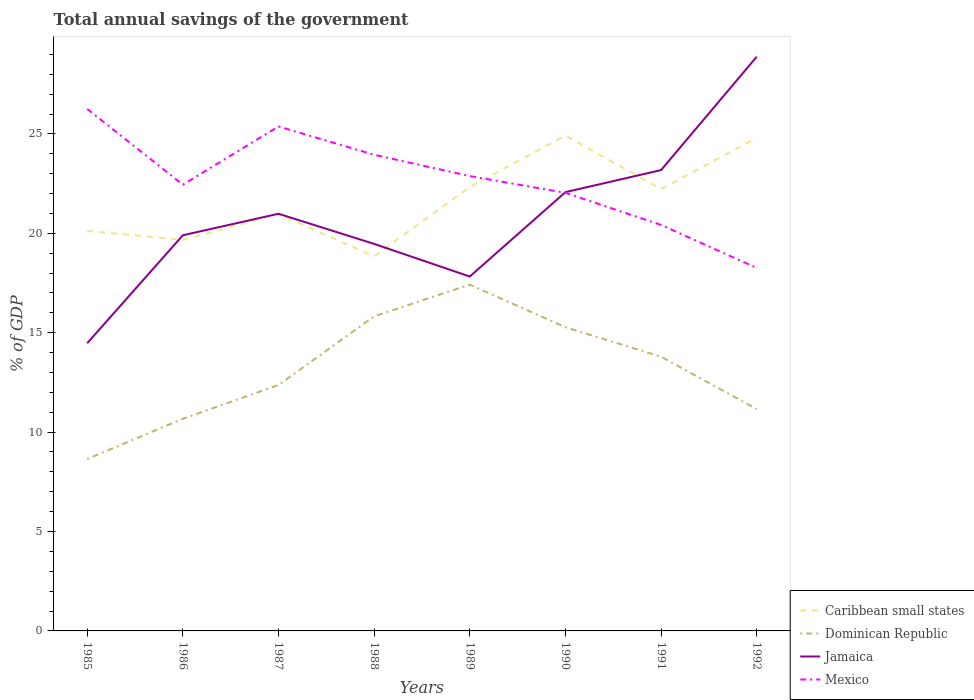Does the line corresponding to Jamaica intersect with the line corresponding to Caribbean small states?
Ensure brevity in your answer.  Yes. Across all years, what is the maximum total annual savings of the government in Dominican Republic?
Provide a succinct answer. 8.65. In which year was the total annual savings of the government in Caribbean small states maximum?
Make the answer very short. 1988. What is the total total annual savings of the government in Mexico in the graph?
Offer a terse response. 0.41. What is the difference between the highest and the second highest total annual savings of the government in Caribbean small states?
Keep it short and to the point. 6.07. Is the total annual savings of the government in Jamaica strictly greater than the total annual savings of the government in Mexico over the years?
Your response must be concise. No. What is the difference between two consecutive major ticks on the Y-axis?
Keep it short and to the point. 5. Are the values on the major ticks of Y-axis written in scientific E-notation?
Your answer should be very brief. No. How are the legend labels stacked?
Your answer should be very brief. Vertical. What is the title of the graph?
Offer a very short reply. Total annual savings of the government. What is the label or title of the Y-axis?
Provide a succinct answer. % of GDP. What is the % of GDP of Caribbean small states in 1985?
Provide a succinct answer. 20.12. What is the % of GDP in Dominican Republic in 1985?
Offer a very short reply. 8.65. What is the % of GDP in Jamaica in 1985?
Ensure brevity in your answer.  14.47. What is the % of GDP of Mexico in 1985?
Ensure brevity in your answer.  26.26. What is the % of GDP of Caribbean small states in 1986?
Keep it short and to the point. 19.67. What is the % of GDP of Dominican Republic in 1986?
Offer a terse response. 10.67. What is the % of GDP of Jamaica in 1986?
Your answer should be compact. 19.9. What is the % of GDP of Mexico in 1986?
Your answer should be very brief. 22.44. What is the % of GDP of Caribbean small states in 1987?
Offer a terse response. 20.96. What is the % of GDP in Dominican Republic in 1987?
Give a very brief answer. 12.37. What is the % of GDP of Jamaica in 1987?
Your answer should be very brief. 20.98. What is the % of GDP of Mexico in 1987?
Offer a very short reply. 25.37. What is the % of GDP of Caribbean small states in 1988?
Your answer should be very brief. 18.84. What is the % of GDP in Dominican Republic in 1988?
Keep it short and to the point. 15.82. What is the % of GDP of Jamaica in 1988?
Provide a short and direct response. 19.47. What is the % of GDP in Mexico in 1988?
Your answer should be compact. 23.95. What is the % of GDP of Caribbean small states in 1989?
Ensure brevity in your answer.  22.33. What is the % of GDP of Dominican Republic in 1989?
Your answer should be compact. 17.42. What is the % of GDP of Jamaica in 1989?
Ensure brevity in your answer.  17.83. What is the % of GDP in Mexico in 1989?
Offer a very short reply. 22.88. What is the % of GDP in Caribbean small states in 1990?
Your answer should be compact. 24.92. What is the % of GDP in Dominican Republic in 1990?
Give a very brief answer. 15.28. What is the % of GDP of Jamaica in 1990?
Your response must be concise. 22.07. What is the % of GDP of Mexico in 1990?
Offer a terse response. 22.04. What is the % of GDP in Caribbean small states in 1991?
Ensure brevity in your answer.  22.22. What is the % of GDP in Dominican Republic in 1991?
Your answer should be compact. 13.79. What is the % of GDP of Jamaica in 1991?
Offer a terse response. 23.18. What is the % of GDP of Mexico in 1991?
Offer a very short reply. 20.42. What is the % of GDP in Caribbean small states in 1992?
Offer a very short reply. 24.8. What is the % of GDP of Dominican Republic in 1992?
Make the answer very short. 11.16. What is the % of GDP of Jamaica in 1992?
Your response must be concise. 28.88. What is the % of GDP of Mexico in 1992?
Offer a very short reply. 18.26. Across all years, what is the maximum % of GDP in Caribbean small states?
Provide a succinct answer. 24.92. Across all years, what is the maximum % of GDP of Dominican Republic?
Offer a very short reply. 17.42. Across all years, what is the maximum % of GDP of Jamaica?
Give a very brief answer. 28.88. Across all years, what is the maximum % of GDP of Mexico?
Keep it short and to the point. 26.26. Across all years, what is the minimum % of GDP in Caribbean small states?
Provide a succinct answer. 18.84. Across all years, what is the minimum % of GDP in Dominican Republic?
Provide a short and direct response. 8.65. Across all years, what is the minimum % of GDP of Jamaica?
Offer a very short reply. 14.47. Across all years, what is the minimum % of GDP in Mexico?
Your answer should be very brief. 18.26. What is the total % of GDP of Caribbean small states in the graph?
Give a very brief answer. 173.86. What is the total % of GDP of Dominican Republic in the graph?
Give a very brief answer. 105.15. What is the total % of GDP of Jamaica in the graph?
Offer a very short reply. 166.78. What is the total % of GDP of Mexico in the graph?
Your response must be concise. 181.62. What is the difference between the % of GDP in Caribbean small states in 1985 and that in 1986?
Your answer should be compact. 0.45. What is the difference between the % of GDP in Dominican Republic in 1985 and that in 1986?
Your answer should be very brief. -2.02. What is the difference between the % of GDP of Jamaica in 1985 and that in 1986?
Your answer should be very brief. -5.43. What is the difference between the % of GDP of Mexico in 1985 and that in 1986?
Your response must be concise. 3.81. What is the difference between the % of GDP of Caribbean small states in 1985 and that in 1987?
Your answer should be compact. -0.84. What is the difference between the % of GDP in Dominican Republic in 1985 and that in 1987?
Offer a terse response. -3.72. What is the difference between the % of GDP of Jamaica in 1985 and that in 1987?
Make the answer very short. -6.51. What is the difference between the % of GDP in Mexico in 1985 and that in 1987?
Give a very brief answer. 0.88. What is the difference between the % of GDP in Caribbean small states in 1985 and that in 1988?
Offer a terse response. 1.28. What is the difference between the % of GDP in Dominican Republic in 1985 and that in 1988?
Your response must be concise. -7.18. What is the difference between the % of GDP in Jamaica in 1985 and that in 1988?
Give a very brief answer. -5. What is the difference between the % of GDP in Mexico in 1985 and that in 1988?
Keep it short and to the point. 2.31. What is the difference between the % of GDP in Caribbean small states in 1985 and that in 1989?
Ensure brevity in your answer.  -2.21. What is the difference between the % of GDP in Dominican Republic in 1985 and that in 1989?
Your response must be concise. -8.77. What is the difference between the % of GDP of Jamaica in 1985 and that in 1989?
Your response must be concise. -3.35. What is the difference between the % of GDP in Mexico in 1985 and that in 1989?
Your response must be concise. 3.38. What is the difference between the % of GDP in Caribbean small states in 1985 and that in 1990?
Make the answer very short. -4.8. What is the difference between the % of GDP in Dominican Republic in 1985 and that in 1990?
Provide a succinct answer. -6.63. What is the difference between the % of GDP in Jamaica in 1985 and that in 1990?
Provide a short and direct response. -7.6. What is the difference between the % of GDP in Mexico in 1985 and that in 1990?
Make the answer very short. 4.22. What is the difference between the % of GDP of Caribbean small states in 1985 and that in 1991?
Make the answer very short. -2.1. What is the difference between the % of GDP of Dominican Republic in 1985 and that in 1991?
Provide a succinct answer. -5.14. What is the difference between the % of GDP in Jamaica in 1985 and that in 1991?
Ensure brevity in your answer.  -8.71. What is the difference between the % of GDP of Mexico in 1985 and that in 1991?
Ensure brevity in your answer.  5.84. What is the difference between the % of GDP in Caribbean small states in 1985 and that in 1992?
Give a very brief answer. -4.68. What is the difference between the % of GDP in Dominican Republic in 1985 and that in 1992?
Offer a very short reply. -2.51. What is the difference between the % of GDP in Jamaica in 1985 and that in 1992?
Your response must be concise. -14.41. What is the difference between the % of GDP in Mexico in 1985 and that in 1992?
Your response must be concise. 8. What is the difference between the % of GDP in Caribbean small states in 1986 and that in 1987?
Provide a succinct answer. -1.29. What is the difference between the % of GDP of Dominican Republic in 1986 and that in 1987?
Offer a terse response. -1.7. What is the difference between the % of GDP in Jamaica in 1986 and that in 1987?
Ensure brevity in your answer.  -1.08. What is the difference between the % of GDP of Mexico in 1986 and that in 1987?
Offer a very short reply. -2.93. What is the difference between the % of GDP of Caribbean small states in 1986 and that in 1988?
Offer a very short reply. 0.83. What is the difference between the % of GDP in Dominican Republic in 1986 and that in 1988?
Keep it short and to the point. -5.15. What is the difference between the % of GDP in Jamaica in 1986 and that in 1988?
Give a very brief answer. 0.43. What is the difference between the % of GDP of Mexico in 1986 and that in 1988?
Give a very brief answer. -1.51. What is the difference between the % of GDP of Caribbean small states in 1986 and that in 1989?
Offer a terse response. -2.66. What is the difference between the % of GDP of Dominican Republic in 1986 and that in 1989?
Ensure brevity in your answer.  -6.75. What is the difference between the % of GDP of Jamaica in 1986 and that in 1989?
Offer a terse response. 2.08. What is the difference between the % of GDP of Mexico in 1986 and that in 1989?
Keep it short and to the point. -0.43. What is the difference between the % of GDP in Caribbean small states in 1986 and that in 1990?
Give a very brief answer. -5.25. What is the difference between the % of GDP of Dominican Republic in 1986 and that in 1990?
Offer a terse response. -4.6. What is the difference between the % of GDP of Jamaica in 1986 and that in 1990?
Offer a very short reply. -2.17. What is the difference between the % of GDP in Mexico in 1986 and that in 1990?
Offer a terse response. 0.41. What is the difference between the % of GDP of Caribbean small states in 1986 and that in 1991?
Provide a succinct answer. -2.55. What is the difference between the % of GDP of Dominican Republic in 1986 and that in 1991?
Your answer should be very brief. -3.12. What is the difference between the % of GDP in Jamaica in 1986 and that in 1991?
Ensure brevity in your answer.  -3.28. What is the difference between the % of GDP in Mexico in 1986 and that in 1991?
Your response must be concise. 2.02. What is the difference between the % of GDP in Caribbean small states in 1986 and that in 1992?
Your answer should be compact. -5.13. What is the difference between the % of GDP in Dominican Republic in 1986 and that in 1992?
Your answer should be very brief. -0.49. What is the difference between the % of GDP in Jamaica in 1986 and that in 1992?
Offer a very short reply. -8.98. What is the difference between the % of GDP of Mexico in 1986 and that in 1992?
Make the answer very short. 4.19. What is the difference between the % of GDP of Caribbean small states in 1987 and that in 1988?
Keep it short and to the point. 2.12. What is the difference between the % of GDP of Dominican Republic in 1987 and that in 1988?
Provide a short and direct response. -3.46. What is the difference between the % of GDP in Jamaica in 1987 and that in 1988?
Give a very brief answer. 1.52. What is the difference between the % of GDP in Mexico in 1987 and that in 1988?
Your answer should be very brief. 1.42. What is the difference between the % of GDP in Caribbean small states in 1987 and that in 1989?
Offer a very short reply. -1.37. What is the difference between the % of GDP of Dominican Republic in 1987 and that in 1989?
Offer a very short reply. -5.05. What is the difference between the % of GDP of Jamaica in 1987 and that in 1989?
Make the answer very short. 3.16. What is the difference between the % of GDP of Mexico in 1987 and that in 1989?
Keep it short and to the point. 2.49. What is the difference between the % of GDP of Caribbean small states in 1987 and that in 1990?
Provide a succinct answer. -3.96. What is the difference between the % of GDP in Dominican Republic in 1987 and that in 1990?
Provide a short and direct response. -2.91. What is the difference between the % of GDP in Jamaica in 1987 and that in 1990?
Your answer should be compact. -1.09. What is the difference between the % of GDP in Mexico in 1987 and that in 1990?
Keep it short and to the point. 3.34. What is the difference between the % of GDP in Caribbean small states in 1987 and that in 1991?
Provide a succinct answer. -1.26. What is the difference between the % of GDP in Dominican Republic in 1987 and that in 1991?
Ensure brevity in your answer.  -1.42. What is the difference between the % of GDP in Jamaica in 1987 and that in 1991?
Your answer should be very brief. -2.2. What is the difference between the % of GDP of Mexico in 1987 and that in 1991?
Ensure brevity in your answer.  4.95. What is the difference between the % of GDP in Caribbean small states in 1987 and that in 1992?
Offer a terse response. -3.84. What is the difference between the % of GDP in Dominican Republic in 1987 and that in 1992?
Offer a terse response. 1.21. What is the difference between the % of GDP in Jamaica in 1987 and that in 1992?
Offer a very short reply. -7.9. What is the difference between the % of GDP of Mexico in 1987 and that in 1992?
Your answer should be very brief. 7.12. What is the difference between the % of GDP in Caribbean small states in 1988 and that in 1989?
Your answer should be compact. -3.49. What is the difference between the % of GDP of Dominican Republic in 1988 and that in 1989?
Provide a short and direct response. -1.59. What is the difference between the % of GDP of Jamaica in 1988 and that in 1989?
Your response must be concise. 1.64. What is the difference between the % of GDP in Mexico in 1988 and that in 1989?
Ensure brevity in your answer.  1.07. What is the difference between the % of GDP of Caribbean small states in 1988 and that in 1990?
Your answer should be compact. -6.07. What is the difference between the % of GDP in Dominican Republic in 1988 and that in 1990?
Give a very brief answer. 0.55. What is the difference between the % of GDP in Jamaica in 1988 and that in 1990?
Your response must be concise. -2.6. What is the difference between the % of GDP in Mexico in 1988 and that in 1990?
Your response must be concise. 1.91. What is the difference between the % of GDP in Caribbean small states in 1988 and that in 1991?
Your answer should be very brief. -3.38. What is the difference between the % of GDP of Dominican Republic in 1988 and that in 1991?
Your response must be concise. 2.03. What is the difference between the % of GDP of Jamaica in 1988 and that in 1991?
Ensure brevity in your answer.  -3.71. What is the difference between the % of GDP of Mexico in 1988 and that in 1991?
Your answer should be compact. 3.53. What is the difference between the % of GDP in Caribbean small states in 1988 and that in 1992?
Your response must be concise. -5.96. What is the difference between the % of GDP in Dominican Republic in 1988 and that in 1992?
Provide a short and direct response. 4.67. What is the difference between the % of GDP in Jamaica in 1988 and that in 1992?
Your answer should be very brief. -9.42. What is the difference between the % of GDP in Mexico in 1988 and that in 1992?
Provide a short and direct response. 5.69. What is the difference between the % of GDP in Caribbean small states in 1989 and that in 1990?
Your answer should be very brief. -2.59. What is the difference between the % of GDP of Dominican Republic in 1989 and that in 1990?
Your answer should be very brief. 2.14. What is the difference between the % of GDP of Jamaica in 1989 and that in 1990?
Give a very brief answer. -4.25. What is the difference between the % of GDP of Mexico in 1989 and that in 1990?
Offer a terse response. 0.84. What is the difference between the % of GDP of Caribbean small states in 1989 and that in 1991?
Ensure brevity in your answer.  0.11. What is the difference between the % of GDP of Dominican Republic in 1989 and that in 1991?
Your answer should be compact. 3.63. What is the difference between the % of GDP in Jamaica in 1989 and that in 1991?
Offer a terse response. -5.35. What is the difference between the % of GDP of Mexico in 1989 and that in 1991?
Offer a very short reply. 2.46. What is the difference between the % of GDP of Caribbean small states in 1989 and that in 1992?
Offer a very short reply. -2.47. What is the difference between the % of GDP of Dominican Republic in 1989 and that in 1992?
Provide a succinct answer. 6.26. What is the difference between the % of GDP of Jamaica in 1989 and that in 1992?
Provide a succinct answer. -11.06. What is the difference between the % of GDP of Mexico in 1989 and that in 1992?
Provide a short and direct response. 4.62. What is the difference between the % of GDP of Caribbean small states in 1990 and that in 1991?
Offer a terse response. 2.7. What is the difference between the % of GDP in Dominican Republic in 1990 and that in 1991?
Ensure brevity in your answer.  1.49. What is the difference between the % of GDP of Jamaica in 1990 and that in 1991?
Provide a short and direct response. -1.11. What is the difference between the % of GDP of Mexico in 1990 and that in 1991?
Provide a short and direct response. 1.62. What is the difference between the % of GDP in Caribbean small states in 1990 and that in 1992?
Give a very brief answer. 0.11. What is the difference between the % of GDP in Dominican Republic in 1990 and that in 1992?
Offer a terse response. 4.12. What is the difference between the % of GDP in Jamaica in 1990 and that in 1992?
Provide a succinct answer. -6.81. What is the difference between the % of GDP in Mexico in 1990 and that in 1992?
Your answer should be compact. 3.78. What is the difference between the % of GDP in Caribbean small states in 1991 and that in 1992?
Offer a very short reply. -2.58. What is the difference between the % of GDP of Dominican Republic in 1991 and that in 1992?
Your response must be concise. 2.63. What is the difference between the % of GDP of Jamaica in 1991 and that in 1992?
Your response must be concise. -5.7. What is the difference between the % of GDP in Mexico in 1991 and that in 1992?
Your answer should be very brief. 2.16. What is the difference between the % of GDP in Caribbean small states in 1985 and the % of GDP in Dominican Republic in 1986?
Provide a succinct answer. 9.45. What is the difference between the % of GDP in Caribbean small states in 1985 and the % of GDP in Jamaica in 1986?
Your response must be concise. 0.22. What is the difference between the % of GDP of Caribbean small states in 1985 and the % of GDP of Mexico in 1986?
Make the answer very short. -2.32. What is the difference between the % of GDP of Dominican Republic in 1985 and the % of GDP of Jamaica in 1986?
Provide a short and direct response. -11.25. What is the difference between the % of GDP of Dominican Republic in 1985 and the % of GDP of Mexico in 1986?
Your answer should be compact. -13.8. What is the difference between the % of GDP in Jamaica in 1985 and the % of GDP in Mexico in 1986?
Your answer should be compact. -7.97. What is the difference between the % of GDP in Caribbean small states in 1985 and the % of GDP in Dominican Republic in 1987?
Offer a terse response. 7.75. What is the difference between the % of GDP of Caribbean small states in 1985 and the % of GDP of Jamaica in 1987?
Your answer should be compact. -0.86. What is the difference between the % of GDP of Caribbean small states in 1985 and the % of GDP of Mexico in 1987?
Your response must be concise. -5.25. What is the difference between the % of GDP in Dominican Republic in 1985 and the % of GDP in Jamaica in 1987?
Keep it short and to the point. -12.34. What is the difference between the % of GDP of Dominican Republic in 1985 and the % of GDP of Mexico in 1987?
Your answer should be very brief. -16.73. What is the difference between the % of GDP in Jamaica in 1985 and the % of GDP in Mexico in 1987?
Offer a terse response. -10.9. What is the difference between the % of GDP of Caribbean small states in 1985 and the % of GDP of Dominican Republic in 1988?
Your answer should be very brief. 4.3. What is the difference between the % of GDP in Caribbean small states in 1985 and the % of GDP in Jamaica in 1988?
Your answer should be compact. 0.65. What is the difference between the % of GDP in Caribbean small states in 1985 and the % of GDP in Mexico in 1988?
Your answer should be compact. -3.83. What is the difference between the % of GDP in Dominican Republic in 1985 and the % of GDP in Jamaica in 1988?
Your answer should be very brief. -10.82. What is the difference between the % of GDP in Dominican Republic in 1985 and the % of GDP in Mexico in 1988?
Provide a succinct answer. -15.3. What is the difference between the % of GDP of Jamaica in 1985 and the % of GDP of Mexico in 1988?
Your answer should be compact. -9.48. What is the difference between the % of GDP of Caribbean small states in 1985 and the % of GDP of Dominican Republic in 1989?
Your response must be concise. 2.7. What is the difference between the % of GDP of Caribbean small states in 1985 and the % of GDP of Jamaica in 1989?
Offer a terse response. 2.29. What is the difference between the % of GDP in Caribbean small states in 1985 and the % of GDP in Mexico in 1989?
Give a very brief answer. -2.76. What is the difference between the % of GDP in Dominican Republic in 1985 and the % of GDP in Jamaica in 1989?
Offer a terse response. -9.18. What is the difference between the % of GDP of Dominican Republic in 1985 and the % of GDP of Mexico in 1989?
Make the answer very short. -14.23. What is the difference between the % of GDP of Jamaica in 1985 and the % of GDP of Mexico in 1989?
Your answer should be compact. -8.41. What is the difference between the % of GDP in Caribbean small states in 1985 and the % of GDP in Dominican Republic in 1990?
Provide a succinct answer. 4.84. What is the difference between the % of GDP of Caribbean small states in 1985 and the % of GDP of Jamaica in 1990?
Provide a succinct answer. -1.95. What is the difference between the % of GDP in Caribbean small states in 1985 and the % of GDP in Mexico in 1990?
Offer a terse response. -1.92. What is the difference between the % of GDP of Dominican Republic in 1985 and the % of GDP of Jamaica in 1990?
Your answer should be compact. -13.42. What is the difference between the % of GDP in Dominican Republic in 1985 and the % of GDP in Mexico in 1990?
Your answer should be very brief. -13.39. What is the difference between the % of GDP of Jamaica in 1985 and the % of GDP of Mexico in 1990?
Offer a very short reply. -7.57. What is the difference between the % of GDP in Caribbean small states in 1985 and the % of GDP in Dominican Republic in 1991?
Ensure brevity in your answer.  6.33. What is the difference between the % of GDP of Caribbean small states in 1985 and the % of GDP of Jamaica in 1991?
Offer a very short reply. -3.06. What is the difference between the % of GDP of Caribbean small states in 1985 and the % of GDP of Mexico in 1991?
Your answer should be compact. -0.3. What is the difference between the % of GDP of Dominican Republic in 1985 and the % of GDP of Jamaica in 1991?
Your answer should be compact. -14.53. What is the difference between the % of GDP in Dominican Republic in 1985 and the % of GDP in Mexico in 1991?
Your answer should be compact. -11.78. What is the difference between the % of GDP of Jamaica in 1985 and the % of GDP of Mexico in 1991?
Provide a short and direct response. -5.95. What is the difference between the % of GDP of Caribbean small states in 1985 and the % of GDP of Dominican Republic in 1992?
Offer a terse response. 8.96. What is the difference between the % of GDP of Caribbean small states in 1985 and the % of GDP of Jamaica in 1992?
Your response must be concise. -8.76. What is the difference between the % of GDP in Caribbean small states in 1985 and the % of GDP in Mexico in 1992?
Make the answer very short. 1.86. What is the difference between the % of GDP in Dominican Republic in 1985 and the % of GDP in Jamaica in 1992?
Give a very brief answer. -20.24. What is the difference between the % of GDP of Dominican Republic in 1985 and the % of GDP of Mexico in 1992?
Provide a short and direct response. -9.61. What is the difference between the % of GDP of Jamaica in 1985 and the % of GDP of Mexico in 1992?
Make the answer very short. -3.79. What is the difference between the % of GDP in Caribbean small states in 1986 and the % of GDP in Dominican Republic in 1987?
Your response must be concise. 7.3. What is the difference between the % of GDP in Caribbean small states in 1986 and the % of GDP in Jamaica in 1987?
Give a very brief answer. -1.31. What is the difference between the % of GDP in Caribbean small states in 1986 and the % of GDP in Mexico in 1987?
Provide a succinct answer. -5.7. What is the difference between the % of GDP in Dominican Republic in 1986 and the % of GDP in Jamaica in 1987?
Ensure brevity in your answer.  -10.31. What is the difference between the % of GDP of Dominican Republic in 1986 and the % of GDP of Mexico in 1987?
Give a very brief answer. -14.7. What is the difference between the % of GDP of Jamaica in 1986 and the % of GDP of Mexico in 1987?
Your answer should be compact. -5.47. What is the difference between the % of GDP of Caribbean small states in 1986 and the % of GDP of Dominican Republic in 1988?
Provide a short and direct response. 3.84. What is the difference between the % of GDP of Caribbean small states in 1986 and the % of GDP of Jamaica in 1988?
Provide a succinct answer. 0.2. What is the difference between the % of GDP of Caribbean small states in 1986 and the % of GDP of Mexico in 1988?
Your answer should be very brief. -4.28. What is the difference between the % of GDP in Dominican Republic in 1986 and the % of GDP in Jamaica in 1988?
Provide a succinct answer. -8.8. What is the difference between the % of GDP of Dominican Republic in 1986 and the % of GDP of Mexico in 1988?
Provide a short and direct response. -13.28. What is the difference between the % of GDP of Jamaica in 1986 and the % of GDP of Mexico in 1988?
Provide a succinct answer. -4.05. What is the difference between the % of GDP in Caribbean small states in 1986 and the % of GDP in Dominican Republic in 1989?
Offer a terse response. 2.25. What is the difference between the % of GDP in Caribbean small states in 1986 and the % of GDP in Jamaica in 1989?
Keep it short and to the point. 1.84. What is the difference between the % of GDP of Caribbean small states in 1986 and the % of GDP of Mexico in 1989?
Your response must be concise. -3.21. What is the difference between the % of GDP of Dominican Republic in 1986 and the % of GDP of Jamaica in 1989?
Provide a succinct answer. -7.15. What is the difference between the % of GDP in Dominican Republic in 1986 and the % of GDP in Mexico in 1989?
Offer a very short reply. -12.21. What is the difference between the % of GDP in Jamaica in 1986 and the % of GDP in Mexico in 1989?
Offer a terse response. -2.98. What is the difference between the % of GDP of Caribbean small states in 1986 and the % of GDP of Dominican Republic in 1990?
Offer a very short reply. 4.39. What is the difference between the % of GDP in Caribbean small states in 1986 and the % of GDP in Jamaica in 1990?
Your response must be concise. -2.4. What is the difference between the % of GDP in Caribbean small states in 1986 and the % of GDP in Mexico in 1990?
Keep it short and to the point. -2.37. What is the difference between the % of GDP of Dominican Republic in 1986 and the % of GDP of Jamaica in 1990?
Ensure brevity in your answer.  -11.4. What is the difference between the % of GDP in Dominican Republic in 1986 and the % of GDP in Mexico in 1990?
Your answer should be compact. -11.37. What is the difference between the % of GDP in Jamaica in 1986 and the % of GDP in Mexico in 1990?
Ensure brevity in your answer.  -2.14. What is the difference between the % of GDP of Caribbean small states in 1986 and the % of GDP of Dominican Republic in 1991?
Provide a short and direct response. 5.88. What is the difference between the % of GDP in Caribbean small states in 1986 and the % of GDP in Jamaica in 1991?
Give a very brief answer. -3.51. What is the difference between the % of GDP in Caribbean small states in 1986 and the % of GDP in Mexico in 1991?
Make the answer very short. -0.75. What is the difference between the % of GDP of Dominican Republic in 1986 and the % of GDP of Jamaica in 1991?
Your answer should be compact. -12.51. What is the difference between the % of GDP in Dominican Republic in 1986 and the % of GDP in Mexico in 1991?
Provide a short and direct response. -9.75. What is the difference between the % of GDP in Jamaica in 1986 and the % of GDP in Mexico in 1991?
Make the answer very short. -0.52. What is the difference between the % of GDP in Caribbean small states in 1986 and the % of GDP in Dominican Republic in 1992?
Keep it short and to the point. 8.51. What is the difference between the % of GDP of Caribbean small states in 1986 and the % of GDP of Jamaica in 1992?
Your answer should be very brief. -9.21. What is the difference between the % of GDP in Caribbean small states in 1986 and the % of GDP in Mexico in 1992?
Your answer should be very brief. 1.41. What is the difference between the % of GDP in Dominican Republic in 1986 and the % of GDP in Jamaica in 1992?
Your response must be concise. -18.21. What is the difference between the % of GDP of Dominican Republic in 1986 and the % of GDP of Mexico in 1992?
Offer a very short reply. -7.59. What is the difference between the % of GDP in Jamaica in 1986 and the % of GDP in Mexico in 1992?
Your answer should be very brief. 1.64. What is the difference between the % of GDP in Caribbean small states in 1987 and the % of GDP in Dominican Republic in 1988?
Provide a short and direct response. 5.14. What is the difference between the % of GDP in Caribbean small states in 1987 and the % of GDP in Jamaica in 1988?
Your response must be concise. 1.49. What is the difference between the % of GDP of Caribbean small states in 1987 and the % of GDP of Mexico in 1988?
Offer a terse response. -2.99. What is the difference between the % of GDP of Dominican Republic in 1987 and the % of GDP of Jamaica in 1988?
Offer a very short reply. -7.1. What is the difference between the % of GDP in Dominican Republic in 1987 and the % of GDP in Mexico in 1988?
Give a very brief answer. -11.58. What is the difference between the % of GDP of Jamaica in 1987 and the % of GDP of Mexico in 1988?
Offer a very short reply. -2.97. What is the difference between the % of GDP in Caribbean small states in 1987 and the % of GDP in Dominican Republic in 1989?
Your answer should be very brief. 3.54. What is the difference between the % of GDP in Caribbean small states in 1987 and the % of GDP in Jamaica in 1989?
Give a very brief answer. 3.13. What is the difference between the % of GDP of Caribbean small states in 1987 and the % of GDP of Mexico in 1989?
Your answer should be very brief. -1.92. What is the difference between the % of GDP of Dominican Republic in 1987 and the % of GDP of Jamaica in 1989?
Ensure brevity in your answer.  -5.46. What is the difference between the % of GDP in Dominican Republic in 1987 and the % of GDP in Mexico in 1989?
Provide a short and direct response. -10.51. What is the difference between the % of GDP of Jamaica in 1987 and the % of GDP of Mexico in 1989?
Provide a short and direct response. -1.89. What is the difference between the % of GDP of Caribbean small states in 1987 and the % of GDP of Dominican Republic in 1990?
Give a very brief answer. 5.68. What is the difference between the % of GDP of Caribbean small states in 1987 and the % of GDP of Jamaica in 1990?
Ensure brevity in your answer.  -1.11. What is the difference between the % of GDP of Caribbean small states in 1987 and the % of GDP of Mexico in 1990?
Offer a terse response. -1.08. What is the difference between the % of GDP of Dominican Republic in 1987 and the % of GDP of Jamaica in 1990?
Keep it short and to the point. -9.7. What is the difference between the % of GDP in Dominican Republic in 1987 and the % of GDP in Mexico in 1990?
Give a very brief answer. -9.67. What is the difference between the % of GDP of Jamaica in 1987 and the % of GDP of Mexico in 1990?
Provide a succinct answer. -1.05. What is the difference between the % of GDP in Caribbean small states in 1987 and the % of GDP in Dominican Republic in 1991?
Offer a very short reply. 7.17. What is the difference between the % of GDP in Caribbean small states in 1987 and the % of GDP in Jamaica in 1991?
Ensure brevity in your answer.  -2.22. What is the difference between the % of GDP in Caribbean small states in 1987 and the % of GDP in Mexico in 1991?
Your answer should be compact. 0.54. What is the difference between the % of GDP of Dominican Republic in 1987 and the % of GDP of Jamaica in 1991?
Ensure brevity in your answer.  -10.81. What is the difference between the % of GDP of Dominican Republic in 1987 and the % of GDP of Mexico in 1991?
Ensure brevity in your answer.  -8.05. What is the difference between the % of GDP in Jamaica in 1987 and the % of GDP in Mexico in 1991?
Your response must be concise. 0.56. What is the difference between the % of GDP of Caribbean small states in 1987 and the % of GDP of Dominican Republic in 1992?
Offer a terse response. 9.8. What is the difference between the % of GDP of Caribbean small states in 1987 and the % of GDP of Jamaica in 1992?
Offer a very short reply. -7.92. What is the difference between the % of GDP in Caribbean small states in 1987 and the % of GDP in Mexico in 1992?
Make the answer very short. 2.7. What is the difference between the % of GDP in Dominican Republic in 1987 and the % of GDP in Jamaica in 1992?
Provide a short and direct response. -16.51. What is the difference between the % of GDP in Dominican Republic in 1987 and the % of GDP in Mexico in 1992?
Make the answer very short. -5.89. What is the difference between the % of GDP of Jamaica in 1987 and the % of GDP of Mexico in 1992?
Make the answer very short. 2.73. What is the difference between the % of GDP in Caribbean small states in 1988 and the % of GDP in Dominican Republic in 1989?
Keep it short and to the point. 1.43. What is the difference between the % of GDP in Caribbean small states in 1988 and the % of GDP in Jamaica in 1989?
Provide a short and direct response. 1.02. What is the difference between the % of GDP of Caribbean small states in 1988 and the % of GDP of Mexico in 1989?
Offer a terse response. -4.03. What is the difference between the % of GDP of Dominican Republic in 1988 and the % of GDP of Jamaica in 1989?
Your answer should be very brief. -2. What is the difference between the % of GDP of Dominican Republic in 1988 and the % of GDP of Mexico in 1989?
Provide a succinct answer. -7.05. What is the difference between the % of GDP of Jamaica in 1988 and the % of GDP of Mexico in 1989?
Provide a succinct answer. -3.41. What is the difference between the % of GDP of Caribbean small states in 1988 and the % of GDP of Dominican Republic in 1990?
Offer a very short reply. 3.57. What is the difference between the % of GDP of Caribbean small states in 1988 and the % of GDP of Jamaica in 1990?
Your answer should be very brief. -3.23. What is the difference between the % of GDP of Caribbean small states in 1988 and the % of GDP of Mexico in 1990?
Keep it short and to the point. -3.19. What is the difference between the % of GDP in Dominican Republic in 1988 and the % of GDP in Jamaica in 1990?
Give a very brief answer. -6.25. What is the difference between the % of GDP in Dominican Republic in 1988 and the % of GDP in Mexico in 1990?
Offer a terse response. -6.21. What is the difference between the % of GDP in Jamaica in 1988 and the % of GDP in Mexico in 1990?
Your answer should be very brief. -2.57. What is the difference between the % of GDP in Caribbean small states in 1988 and the % of GDP in Dominican Republic in 1991?
Provide a succinct answer. 5.05. What is the difference between the % of GDP in Caribbean small states in 1988 and the % of GDP in Jamaica in 1991?
Your answer should be very brief. -4.34. What is the difference between the % of GDP in Caribbean small states in 1988 and the % of GDP in Mexico in 1991?
Provide a short and direct response. -1.58. What is the difference between the % of GDP of Dominican Republic in 1988 and the % of GDP of Jamaica in 1991?
Give a very brief answer. -7.36. What is the difference between the % of GDP of Dominican Republic in 1988 and the % of GDP of Mexico in 1991?
Give a very brief answer. -4.6. What is the difference between the % of GDP in Jamaica in 1988 and the % of GDP in Mexico in 1991?
Make the answer very short. -0.95. What is the difference between the % of GDP in Caribbean small states in 1988 and the % of GDP in Dominican Republic in 1992?
Your response must be concise. 7.69. What is the difference between the % of GDP of Caribbean small states in 1988 and the % of GDP of Jamaica in 1992?
Provide a short and direct response. -10.04. What is the difference between the % of GDP of Caribbean small states in 1988 and the % of GDP of Mexico in 1992?
Provide a short and direct response. 0.59. What is the difference between the % of GDP in Dominican Republic in 1988 and the % of GDP in Jamaica in 1992?
Provide a succinct answer. -13.06. What is the difference between the % of GDP of Dominican Republic in 1988 and the % of GDP of Mexico in 1992?
Your response must be concise. -2.43. What is the difference between the % of GDP in Jamaica in 1988 and the % of GDP in Mexico in 1992?
Keep it short and to the point. 1.21. What is the difference between the % of GDP in Caribbean small states in 1989 and the % of GDP in Dominican Republic in 1990?
Your answer should be very brief. 7.05. What is the difference between the % of GDP in Caribbean small states in 1989 and the % of GDP in Jamaica in 1990?
Offer a terse response. 0.26. What is the difference between the % of GDP in Caribbean small states in 1989 and the % of GDP in Mexico in 1990?
Your answer should be compact. 0.29. What is the difference between the % of GDP of Dominican Republic in 1989 and the % of GDP of Jamaica in 1990?
Keep it short and to the point. -4.65. What is the difference between the % of GDP of Dominican Republic in 1989 and the % of GDP of Mexico in 1990?
Your response must be concise. -4.62. What is the difference between the % of GDP of Jamaica in 1989 and the % of GDP of Mexico in 1990?
Ensure brevity in your answer.  -4.21. What is the difference between the % of GDP in Caribbean small states in 1989 and the % of GDP in Dominican Republic in 1991?
Make the answer very short. 8.54. What is the difference between the % of GDP in Caribbean small states in 1989 and the % of GDP in Jamaica in 1991?
Your response must be concise. -0.85. What is the difference between the % of GDP of Caribbean small states in 1989 and the % of GDP of Mexico in 1991?
Provide a succinct answer. 1.91. What is the difference between the % of GDP of Dominican Republic in 1989 and the % of GDP of Jamaica in 1991?
Offer a very short reply. -5.76. What is the difference between the % of GDP in Dominican Republic in 1989 and the % of GDP in Mexico in 1991?
Keep it short and to the point. -3. What is the difference between the % of GDP of Jamaica in 1989 and the % of GDP of Mexico in 1991?
Ensure brevity in your answer.  -2.6. What is the difference between the % of GDP of Caribbean small states in 1989 and the % of GDP of Dominican Republic in 1992?
Make the answer very short. 11.17. What is the difference between the % of GDP of Caribbean small states in 1989 and the % of GDP of Jamaica in 1992?
Provide a succinct answer. -6.55. What is the difference between the % of GDP in Caribbean small states in 1989 and the % of GDP in Mexico in 1992?
Offer a terse response. 4.07. What is the difference between the % of GDP of Dominican Republic in 1989 and the % of GDP of Jamaica in 1992?
Ensure brevity in your answer.  -11.47. What is the difference between the % of GDP in Dominican Republic in 1989 and the % of GDP in Mexico in 1992?
Ensure brevity in your answer.  -0.84. What is the difference between the % of GDP in Jamaica in 1989 and the % of GDP in Mexico in 1992?
Your answer should be very brief. -0.43. What is the difference between the % of GDP of Caribbean small states in 1990 and the % of GDP of Dominican Republic in 1991?
Your answer should be compact. 11.13. What is the difference between the % of GDP in Caribbean small states in 1990 and the % of GDP in Jamaica in 1991?
Give a very brief answer. 1.74. What is the difference between the % of GDP of Caribbean small states in 1990 and the % of GDP of Mexico in 1991?
Provide a short and direct response. 4.5. What is the difference between the % of GDP in Dominican Republic in 1990 and the % of GDP in Jamaica in 1991?
Your answer should be very brief. -7.9. What is the difference between the % of GDP in Dominican Republic in 1990 and the % of GDP in Mexico in 1991?
Ensure brevity in your answer.  -5.14. What is the difference between the % of GDP in Jamaica in 1990 and the % of GDP in Mexico in 1991?
Your answer should be compact. 1.65. What is the difference between the % of GDP in Caribbean small states in 1990 and the % of GDP in Dominican Republic in 1992?
Ensure brevity in your answer.  13.76. What is the difference between the % of GDP in Caribbean small states in 1990 and the % of GDP in Jamaica in 1992?
Ensure brevity in your answer.  -3.96. What is the difference between the % of GDP in Caribbean small states in 1990 and the % of GDP in Mexico in 1992?
Keep it short and to the point. 6.66. What is the difference between the % of GDP in Dominican Republic in 1990 and the % of GDP in Jamaica in 1992?
Keep it short and to the point. -13.61. What is the difference between the % of GDP of Dominican Republic in 1990 and the % of GDP of Mexico in 1992?
Your answer should be very brief. -2.98. What is the difference between the % of GDP of Jamaica in 1990 and the % of GDP of Mexico in 1992?
Give a very brief answer. 3.81. What is the difference between the % of GDP in Caribbean small states in 1991 and the % of GDP in Dominican Republic in 1992?
Keep it short and to the point. 11.06. What is the difference between the % of GDP in Caribbean small states in 1991 and the % of GDP in Jamaica in 1992?
Your answer should be compact. -6.66. What is the difference between the % of GDP of Caribbean small states in 1991 and the % of GDP of Mexico in 1992?
Keep it short and to the point. 3.96. What is the difference between the % of GDP of Dominican Republic in 1991 and the % of GDP of Jamaica in 1992?
Offer a very short reply. -15.09. What is the difference between the % of GDP of Dominican Republic in 1991 and the % of GDP of Mexico in 1992?
Provide a short and direct response. -4.47. What is the difference between the % of GDP in Jamaica in 1991 and the % of GDP in Mexico in 1992?
Provide a short and direct response. 4.92. What is the average % of GDP in Caribbean small states per year?
Ensure brevity in your answer.  21.73. What is the average % of GDP in Dominican Republic per year?
Offer a very short reply. 13.14. What is the average % of GDP in Jamaica per year?
Your answer should be very brief. 20.85. What is the average % of GDP of Mexico per year?
Provide a short and direct response. 22.7. In the year 1985, what is the difference between the % of GDP of Caribbean small states and % of GDP of Dominican Republic?
Offer a terse response. 11.47. In the year 1985, what is the difference between the % of GDP in Caribbean small states and % of GDP in Jamaica?
Ensure brevity in your answer.  5.65. In the year 1985, what is the difference between the % of GDP of Caribbean small states and % of GDP of Mexico?
Make the answer very short. -6.14. In the year 1985, what is the difference between the % of GDP of Dominican Republic and % of GDP of Jamaica?
Give a very brief answer. -5.83. In the year 1985, what is the difference between the % of GDP in Dominican Republic and % of GDP in Mexico?
Your answer should be compact. -17.61. In the year 1985, what is the difference between the % of GDP in Jamaica and % of GDP in Mexico?
Offer a terse response. -11.79. In the year 1986, what is the difference between the % of GDP in Caribbean small states and % of GDP in Dominican Republic?
Keep it short and to the point. 9. In the year 1986, what is the difference between the % of GDP of Caribbean small states and % of GDP of Jamaica?
Make the answer very short. -0.23. In the year 1986, what is the difference between the % of GDP in Caribbean small states and % of GDP in Mexico?
Provide a short and direct response. -2.78. In the year 1986, what is the difference between the % of GDP in Dominican Republic and % of GDP in Jamaica?
Your answer should be very brief. -9.23. In the year 1986, what is the difference between the % of GDP of Dominican Republic and % of GDP of Mexico?
Keep it short and to the point. -11.77. In the year 1986, what is the difference between the % of GDP in Jamaica and % of GDP in Mexico?
Provide a short and direct response. -2.54. In the year 1987, what is the difference between the % of GDP of Caribbean small states and % of GDP of Dominican Republic?
Offer a terse response. 8.59. In the year 1987, what is the difference between the % of GDP in Caribbean small states and % of GDP in Jamaica?
Your answer should be very brief. -0.02. In the year 1987, what is the difference between the % of GDP of Caribbean small states and % of GDP of Mexico?
Offer a very short reply. -4.41. In the year 1987, what is the difference between the % of GDP of Dominican Republic and % of GDP of Jamaica?
Make the answer very short. -8.61. In the year 1987, what is the difference between the % of GDP in Dominican Republic and % of GDP in Mexico?
Offer a terse response. -13. In the year 1987, what is the difference between the % of GDP in Jamaica and % of GDP in Mexico?
Keep it short and to the point. -4.39. In the year 1988, what is the difference between the % of GDP of Caribbean small states and % of GDP of Dominican Republic?
Provide a succinct answer. 3.02. In the year 1988, what is the difference between the % of GDP in Caribbean small states and % of GDP in Jamaica?
Your answer should be compact. -0.62. In the year 1988, what is the difference between the % of GDP in Caribbean small states and % of GDP in Mexico?
Make the answer very short. -5.11. In the year 1988, what is the difference between the % of GDP of Dominican Republic and % of GDP of Jamaica?
Your answer should be compact. -3.64. In the year 1988, what is the difference between the % of GDP of Dominican Republic and % of GDP of Mexico?
Your answer should be compact. -8.13. In the year 1988, what is the difference between the % of GDP in Jamaica and % of GDP in Mexico?
Your answer should be very brief. -4.48. In the year 1989, what is the difference between the % of GDP of Caribbean small states and % of GDP of Dominican Republic?
Your response must be concise. 4.91. In the year 1989, what is the difference between the % of GDP of Caribbean small states and % of GDP of Jamaica?
Your answer should be compact. 4.5. In the year 1989, what is the difference between the % of GDP of Caribbean small states and % of GDP of Mexico?
Ensure brevity in your answer.  -0.55. In the year 1989, what is the difference between the % of GDP of Dominican Republic and % of GDP of Jamaica?
Offer a terse response. -0.41. In the year 1989, what is the difference between the % of GDP of Dominican Republic and % of GDP of Mexico?
Provide a succinct answer. -5.46. In the year 1989, what is the difference between the % of GDP of Jamaica and % of GDP of Mexico?
Keep it short and to the point. -5.05. In the year 1990, what is the difference between the % of GDP of Caribbean small states and % of GDP of Dominican Republic?
Offer a very short reply. 9.64. In the year 1990, what is the difference between the % of GDP in Caribbean small states and % of GDP in Jamaica?
Your answer should be very brief. 2.85. In the year 1990, what is the difference between the % of GDP in Caribbean small states and % of GDP in Mexico?
Make the answer very short. 2.88. In the year 1990, what is the difference between the % of GDP of Dominican Republic and % of GDP of Jamaica?
Give a very brief answer. -6.79. In the year 1990, what is the difference between the % of GDP of Dominican Republic and % of GDP of Mexico?
Provide a succinct answer. -6.76. In the year 1990, what is the difference between the % of GDP in Jamaica and % of GDP in Mexico?
Provide a short and direct response. 0.03. In the year 1991, what is the difference between the % of GDP in Caribbean small states and % of GDP in Dominican Republic?
Offer a very short reply. 8.43. In the year 1991, what is the difference between the % of GDP of Caribbean small states and % of GDP of Jamaica?
Offer a very short reply. -0.96. In the year 1991, what is the difference between the % of GDP of Caribbean small states and % of GDP of Mexico?
Ensure brevity in your answer.  1.8. In the year 1991, what is the difference between the % of GDP in Dominican Republic and % of GDP in Jamaica?
Your answer should be compact. -9.39. In the year 1991, what is the difference between the % of GDP of Dominican Republic and % of GDP of Mexico?
Make the answer very short. -6.63. In the year 1991, what is the difference between the % of GDP in Jamaica and % of GDP in Mexico?
Your answer should be very brief. 2.76. In the year 1992, what is the difference between the % of GDP in Caribbean small states and % of GDP in Dominican Republic?
Offer a very short reply. 13.65. In the year 1992, what is the difference between the % of GDP in Caribbean small states and % of GDP in Jamaica?
Keep it short and to the point. -4.08. In the year 1992, what is the difference between the % of GDP of Caribbean small states and % of GDP of Mexico?
Your response must be concise. 6.55. In the year 1992, what is the difference between the % of GDP of Dominican Republic and % of GDP of Jamaica?
Give a very brief answer. -17.73. In the year 1992, what is the difference between the % of GDP in Dominican Republic and % of GDP in Mexico?
Offer a terse response. -7.1. In the year 1992, what is the difference between the % of GDP of Jamaica and % of GDP of Mexico?
Offer a very short reply. 10.63. What is the ratio of the % of GDP of Caribbean small states in 1985 to that in 1986?
Ensure brevity in your answer.  1.02. What is the ratio of the % of GDP of Dominican Republic in 1985 to that in 1986?
Your answer should be very brief. 0.81. What is the ratio of the % of GDP in Jamaica in 1985 to that in 1986?
Keep it short and to the point. 0.73. What is the ratio of the % of GDP in Mexico in 1985 to that in 1986?
Offer a very short reply. 1.17. What is the ratio of the % of GDP of Caribbean small states in 1985 to that in 1987?
Ensure brevity in your answer.  0.96. What is the ratio of the % of GDP in Dominican Republic in 1985 to that in 1987?
Your answer should be compact. 0.7. What is the ratio of the % of GDP in Jamaica in 1985 to that in 1987?
Offer a terse response. 0.69. What is the ratio of the % of GDP in Mexico in 1985 to that in 1987?
Offer a very short reply. 1.03. What is the ratio of the % of GDP in Caribbean small states in 1985 to that in 1988?
Make the answer very short. 1.07. What is the ratio of the % of GDP in Dominican Republic in 1985 to that in 1988?
Your answer should be very brief. 0.55. What is the ratio of the % of GDP in Jamaica in 1985 to that in 1988?
Ensure brevity in your answer.  0.74. What is the ratio of the % of GDP of Mexico in 1985 to that in 1988?
Make the answer very short. 1.1. What is the ratio of the % of GDP of Caribbean small states in 1985 to that in 1989?
Your response must be concise. 0.9. What is the ratio of the % of GDP of Dominican Republic in 1985 to that in 1989?
Provide a succinct answer. 0.5. What is the ratio of the % of GDP of Jamaica in 1985 to that in 1989?
Ensure brevity in your answer.  0.81. What is the ratio of the % of GDP of Mexico in 1985 to that in 1989?
Your answer should be compact. 1.15. What is the ratio of the % of GDP of Caribbean small states in 1985 to that in 1990?
Ensure brevity in your answer.  0.81. What is the ratio of the % of GDP in Dominican Republic in 1985 to that in 1990?
Offer a terse response. 0.57. What is the ratio of the % of GDP in Jamaica in 1985 to that in 1990?
Give a very brief answer. 0.66. What is the ratio of the % of GDP of Mexico in 1985 to that in 1990?
Your answer should be very brief. 1.19. What is the ratio of the % of GDP in Caribbean small states in 1985 to that in 1991?
Ensure brevity in your answer.  0.91. What is the ratio of the % of GDP in Dominican Republic in 1985 to that in 1991?
Ensure brevity in your answer.  0.63. What is the ratio of the % of GDP of Jamaica in 1985 to that in 1991?
Provide a succinct answer. 0.62. What is the ratio of the % of GDP in Mexico in 1985 to that in 1991?
Offer a terse response. 1.29. What is the ratio of the % of GDP of Caribbean small states in 1985 to that in 1992?
Provide a succinct answer. 0.81. What is the ratio of the % of GDP of Dominican Republic in 1985 to that in 1992?
Make the answer very short. 0.77. What is the ratio of the % of GDP in Jamaica in 1985 to that in 1992?
Offer a terse response. 0.5. What is the ratio of the % of GDP of Mexico in 1985 to that in 1992?
Your response must be concise. 1.44. What is the ratio of the % of GDP in Caribbean small states in 1986 to that in 1987?
Offer a very short reply. 0.94. What is the ratio of the % of GDP of Dominican Republic in 1986 to that in 1987?
Give a very brief answer. 0.86. What is the ratio of the % of GDP in Jamaica in 1986 to that in 1987?
Offer a very short reply. 0.95. What is the ratio of the % of GDP in Mexico in 1986 to that in 1987?
Give a very brief answer. 0.88. What is the ratio of the % of GDP in Caribbean small states in 1986 to that in 1988?
Make the answer very short. 1.04. What is the ratio of the % of GDP of Dominican Republic in 1986 to that in 1988?
Your answer should be very brief. 0.67. What is the ratio of the % of GDP of Jamaica in 1986 to that in 1988?
Offer a terse response. 1.02. What is the ratio of the % of GDP of Mexico in 1986 to that in 1988?
Your answer should be compact. 0.94. What is the ratio of the % of GDP in Caribbean small states in 1986 to that in 1989?
Provide a succinct answer. 0.88. What is the ratio of the % of GDP of Dominican Republic in 1986 to that in 1989?
Offer a terse response. 0.61. What is the ratio of the % of GDP of Jamaica in 1986 to that in 1989?
Your response must be concise. 1.12. What is the ratio of the % of GDP in Mexico in 1986 to that in 1989?
Keep it short and to the point. 0.98. What is the ratio of the % of GDP of Caribbean small states in 1986 to that in 1990?
Make the answer very short. 0.79. What is the ratio of the % of GDP of Dominican Republic in 1986 to that in 1990?
Your response must be concise. 0.7. What is the ratio of the % of GDP of Jamaica in 1986 to that in 1990?
Offer a terse response. 0.9. What is the ratio of the % of GDP in Mexico in 1986 to that in 1990?
Make the answer very short. 1.02. What is the ratio of the % of GDP of Caribbean small states in 1986 to that in 1991?
Give a very brief answer. 0.89. What is the ratio of the % of GDP in Dominican Republic in 1986 to that in 1991?
Provide a succinct answer. 0.77. What is the ratio of the % of GDP of Jamaica in 1986 to that in 1991?
Offer a very short reply. 0.86. What is the ratio of the % of GDP in Mexico in 1986 to that in 1991?
Give a very brief answer. 1.1. What is the ratio of the % of GDP in Caribbean small states in 1986 to that in 1992?
Provide a short and direct response. 0.79. What is the ratio of the % of GDP of Dominican Republic in 1986 to that in 1992?
Your response must be concise. 0.96. What is the ratio of the % of GDP in Jamaica in 1986 to that in 1992?
Your answer should be compact. 0.69. What is the ratio of the % of GDP in Mexico in 1986 to that in 1992?
Ensure brevity in your answer.  1.23. What is the ratio of the % of GDP of Caribbean small states in 1987 to that in 1988?
Ensure brevity in your answer.  1.11. What is the ratio of the % of GDP of Dominican Republic in 1987 to that in 1988?
Provide a succinct answer. 0.78. What is the ratio of the % of GDP of Jamaica in 1987 to that in 1988?
Give a very brief answer. 1.08. What is the ratio of the % of GDP in Mexico in 1987 to that in 1988?
Offer a terse response. 1.06. What is the ratio of the % of GDP in Caribbean small states in 1987 to that in 1989?
Provide a succinct answer. 0.94. What is the ratio of the % of GDP in Dominican Republic in 1987 to that in 1989?
Keep it short and to the point. 0.71. What is the ratio of the % of GDP of Jamaica in 1987 to that in 1989?
Keep it short and to the point. 1.18. What is the ratio of the % of GDP in Mexico in 1987 to that in 1989?
Provide a short and direct response. 1.11. What is the ratio of the % of GDP of Caribbean small states in 1987 to that in 1990?
Offer a very short reply. 0.84. What is the ratio of the % of GDP in Dominican Republic in 1987 to that in 1990?
Make the answer very short. 0.81. What is the ratio of the % of GDP of Jamaica in 1987 to that in 1990?
Your answer should be compact. 0.95. What is the ratio of the % of GDP in Mexico in 1987 to that in 1990?
Keep it short and to the point. 1.15. What is the ratio of the % of GDP in Caribbean small states in 1987 to that in 1991?
Ensure brevity in your answer.  0.94. What is the ratio of the % of GDP of Dominican Republic in 1987 to that in 1991?
Your answer should be compact. 0.9. What is the ratio of the % of GDP in Jamaica in 1987 to that in 1991?
Provide a short and direct response. 0.91. What is the ratio of the % of GDP in Mexico in 1987 to that in 1991?
Offer a terse response. 1.24. What is the ratio of the % of GDP in Caribbean small states in 1987 to that in 1992?
Your answer should be compact. 0.85. What is the ratio of the % of GDP of Dominican Republic in 1987 to that in 1992?
Offer a terse response. 1.11. What is the ratio of the % of GDP of Jamaica in 1987 to that in 1992?
Keep it short and to the point. 0.73. What is the ratio of the % of GDP in Mexico in 1987 to that in 1992?
Offer a very short reply. 1.39. What is the ratio of the % of GDP of Caribbean small states in 1988 to that in 1989?
Ensure brevity in your answer.  0.84. What is the ratio of the % of GDP in Dominican Republic in 1988 to that in 1989?
Make the answer very short. 0.91. What is the ratio of the % of GDP of Jamaica in 1988 to that in 1989?
Your answer should be very brief. 1.09. What is the ratio of the % of GDP of Mexico in 1988 to that in 1989?
Provide a short and direct response. 1.05. What is the ratio of the % of GDP in Caribbean small states in 1988 to that in 1990?
Provide a short and direct response. 0.76. What is the ratio of the % of GDP in Dominican Republic in 1988 to that in 1990?
Keep it short and to the point. 1.04. What is the ratio of the % of GDP of Jamaica in 1988 to that in 1990?
Offer a terse response. 0.88. What is the ratio of the % of GDP of Mexico in 1988 to that in 1990?
Provide a succinct answer. 1.09. What is the ratio of the % of GDP in Caribbean small states in 1988 to that in 1991?
Your answer should be compact. 0.85. What is the ratio of the % of GDP of Dominican Republic in 1988 to that in 1991?
Provide a succinct answer. 1.15. What is the ratio of the % of GDP of Jamaica in 1988 to that in 1991?
Ensure brevity in your answer.  0.84. What is the ratio of the % of GDP of Mexico in 1988 to that in 1991?
Keep it short and to the point. 1.17. What is the ratio of the % of GDP of Caribbean small states in 1988 to that in 1992?
Give a very brief answer. 0.76. What is the ratio of the % of GDP in Dominican Republic in 1988 to that in 1992?
Provide a short and direct response. 1.42. What is the ratio of the % of GDP of Jamaica in 1988 to that in 1992?
Give a very brief answer. 0.67. What is the ratio of the % of GDP in Mexico in 1988 to that in 1992?
Offer a terse response. 1.31. What is the ratio of the % of GDP in Caribbean small states in 1989 to that in 1990?
Give a very brief answer. 0.9. What is the ratio of the % of GDP of Dominican Republic in 1989 to that in 1990?
Offer a very short reply. 1.14. What is the ratio of the % of GDP of Jamaica in 1989 to that in 1990?
Offer a terse response. 0.81. What is the ratio of the % of GDP of Mexico in 1989 to that in 1990?
Your response must be concise. 1.04. What is the ratio of the % of GDP in Caribbean small states in 1989 to that in 1991?
Provide a short and direct response. 1. What is the ratio of the % of GDP in Dominican Republic in 1989 to that in 1991?
Provide a succinct answer. 1.26. What is the ratio of the % of GDP in Jamaica in 1989 to that in 1991?
Make the answer very short. 0.77. What is the ratio of the % of GDP of Mexico in 1989 to that in 1991?
Provide a short and direct response. 1.12. What is the ratio of the % of GDP of Caribbean small states in 1989 to that in 1992?
Ensure brevity in your answer.  0.9. What is the ratio of the % of GDP of Dominican Republic in 1989 to that in 1992?
Give a very brief answer. 1.56. What is the ratio of the % of GDP in Jamaica in 1989 to that in 1992?
Offer a terse response. 0.62. What is the ratio of the % of GDP in Mexico in 1989 to that in 1992?
Your answer should be very brief. 1.25. What is the ratio of the % of GDP of Caribbean small states in 1990 to that in 1991?
Your answer should be very brief. 1.12. What is the ratio of the % of GDP in Dominican Republic in 1990 to that in 1991?
Your answer should be compact. 1.11. What is the ratio of the % of GDP of Jamaica in 1990 to that in 1991?
Your response must be concise. 0.95. What is the ratio of the % of GDP in Mexico in 1990 to that in 1991?
Your answer should be compact. 1.08. What is the ratio of the % of GDP of Caribbean small states in 1990 to that in 1992?
Offer a very short reply. 1. What is the ratio of the % of GDP in Dominican Republic in 1990 to that in 1992?
Give a very brief answer. 1.37. What is the ratio of the % of GDP of Jamaica in 1990 to that in 1992?
Provide a short and direct response. 0.76. What is the ratio of the % of GDP of Mexico in 1990 to that in 1992?
Ensure brevity in your answer.  1.21. What is the ratio of the % of GDP in Caribbean small states in 1991 to that in 1992?
Make the answer very short. 0.9. What is the ratio of the % of GDP of Dominican Republic in 1991 to that in 1992?
Keep it short and to the point. 1.24. What is the ratio of the % of GDP in Jamaica in 1991 to that in 1992?
Ensure brevity in your answer.  0.8. What is the ratio of the % of GDP in Mexico in 1991 to that in 1992?
Offer a terse response. 1.12. What is the difference between the highest and the second highest % of GDP in Caribbean small states?
Your answer should be very brief. 0.11. What is the difference between the highest and the second highest % of GDP in Dominican Republic?
Provide a succinct answer. 1.59. What is the difference between the highest and the second highest % of GDP in Jamaica?
Your answer should be compact. 5.7. What is the difference between the highest and the second highest % of GDP of Mexico?
Provide a short and direct response. 0.88. What is the difference between the highest and the lowest % of GDP of Caribbean small states?
Provide a short and direct response. 6.07. What is the difference between the highest and the lowest % of GDP in Dominican Republic?
Provide a short and direct response. 8.77. What is the difference between the highest and the lowest % of GDP in Jamaica?
Provide a short and direct response. 14.41. What is the difference between the highest and the lowest % of GDP of Mexico?
Keep it short and to the point. 8. 